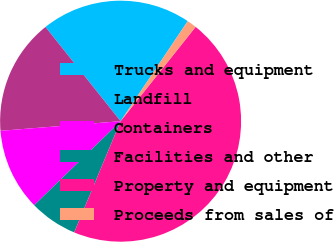<chart> <loc_0><loc_0><loc_500><loc_500><pie_chart><fcel>Trucks and equipment<fcel>Landfill<fcel>Containers<fcel>Facilities and other<fcel>Property and equipment<fcel>Proceeds from sales of<nl><fcel>20.12%<fcel>15.56%<fcel>11.0%<fcel>6.44%<fcel>45.6%<fcel>1.29%<nl></chart> 